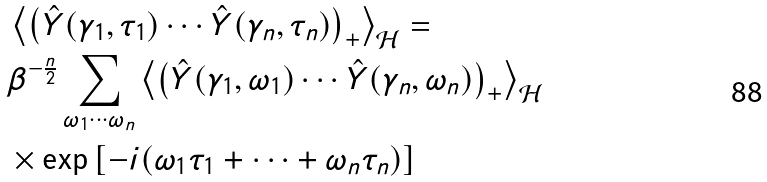<formula> <loc_0><loc_0><loc_500><loc_500>& \left \langle \left ( \hat { Y } ( \gamma _ { 1 } , \tau _ { 1 } ) \cdots \hat { Y } ( \gamma _ { n } , \tau _ { n } ) \right ) _ { + } \right \rangle _ { \mathcal { H } } = \\ & \beta ^ { - \frac { n } { 2 } } \sum _ { \omega _ { 1 } \cdots \omega _ { n } } \left \langle \left ( \hat { Y } ( \gamma _ { 1 } , \omega _ { 1 } ) \cdots \hat { Y } ( \gamma _ { n } , \omega _ { n } ) \right ) _ { + } \right \rangle _ { \mathcal { H } } \\ & \times \exp \left [ - i ( \omega _ { 1 } \tau _ { 1 } + \cdots + \omega _ { n } \tau _ { n } ) \right ]</formula> 